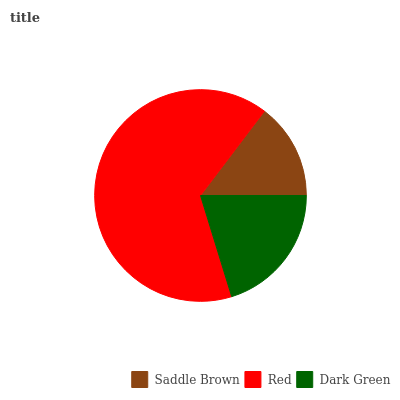Is Saddle Brown the minimum?
Answer yes or no. Yes. Is Red the maximum?
Answer yes or no. Yes. Is Dark Green the minimum?
Answer yes or no. No. Is Dark Green the maximum?
Answer yes or no. No. Is Red greater than Dark Green?
Answer yes or no. Yes. Is Dark Green less than Red?
Answer yes or no. Yes. Is Dark Green greater than Red?
Answer yes or no. No. Is Red less than Dark Green?
Answer yes or no. No. Is Dark Green the high median?
Answer yes or no. Yes. Is Dark Green the low median?
Answer yes or no. Yes. Is Red the high median?
Answer yes or no. No. Is Red the low median?
Answer yes or no. No. 